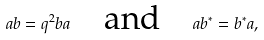<formula> <loc_0><loc_0><loc_500><loc_500>a b = q ^ { 2 } b a \quad \text {and} \quad { a b ^ { * } = b ^ { * } a } ,</formula> 